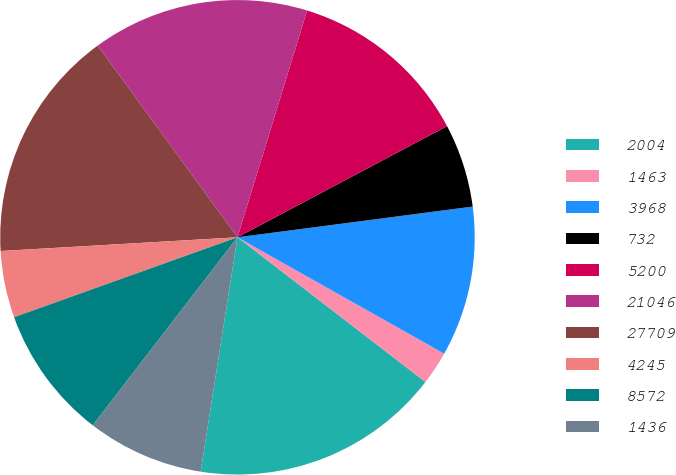<chart> <loc_0><loc_0><loc_500><loc_500><pie_chart><fcel>2004<fcel>1463<fcel>3968<fcel>732<fcel>5200<fcel>21046<fcel>27709<fcel>4245<fcel>8572<fcel>1436<nl><fcel>17.04%<fcel>2.28%<fcel>10.23%<fcel>5.69%<fcel>12.5%<fcel>14.77%<fcel>15.9%<fcel>4.55%<fcel>9.09%<fcel>7.96%<nl></chart> 